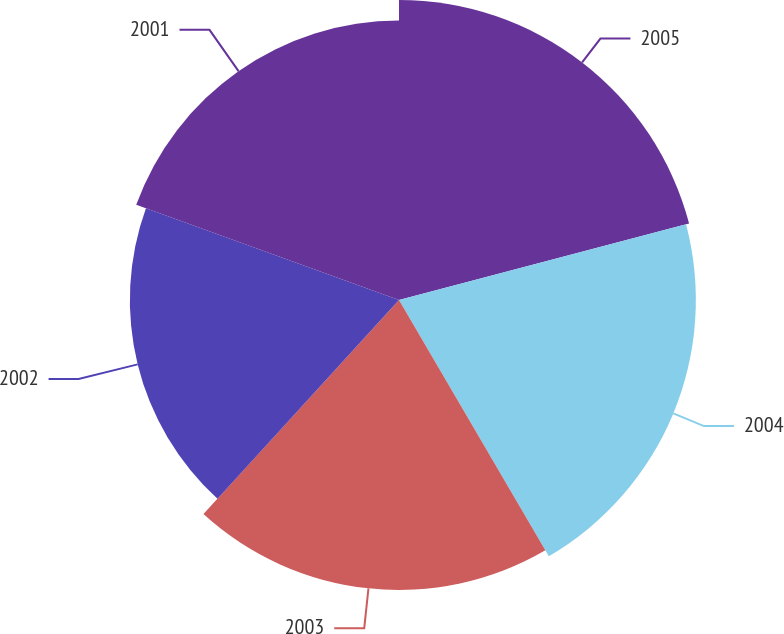<chart> <loc_0><loc_0><loc_500><loc_500><pie_chart><fcel>2005<fcel>2004<fcel>2003<fcel>2002<fcel>2001<nl><fcel>20.9%<fcel>20.68%<fcel>20.2%<fcel>18.75%<fcel>19.47%<nl></chart> 